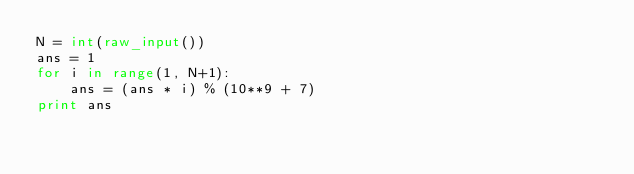<code> <loc_0><loc_0><loc_500><loc_500><_Python_>N = int(raw_input())
ans = 1
for i in range(1, N+1):
    ans = (ans * i) % (10**9 + 7)
print ans</code> 